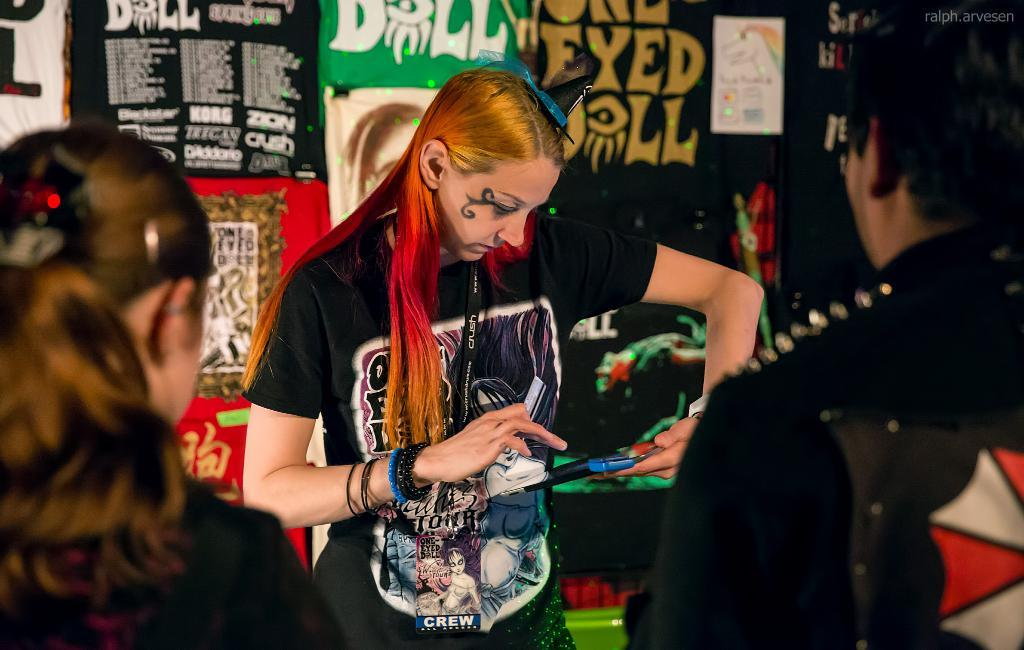How many people are in the image? There are three persons standing in the image. Can you describe the clothing of one of the persons? One person is wearing a black dress. What is the person in the black dress holding? The person in the black dress is holding an object. What can be seen in the background of the image? There are banners in the background of the image. What is the color scheme of the banners? The banners have multiple colors. What type of apparel is the person in the black dress using to climb the cave in the image? There is no cave present in the image, and the person in the black dress is not depicted as climbing anything. 